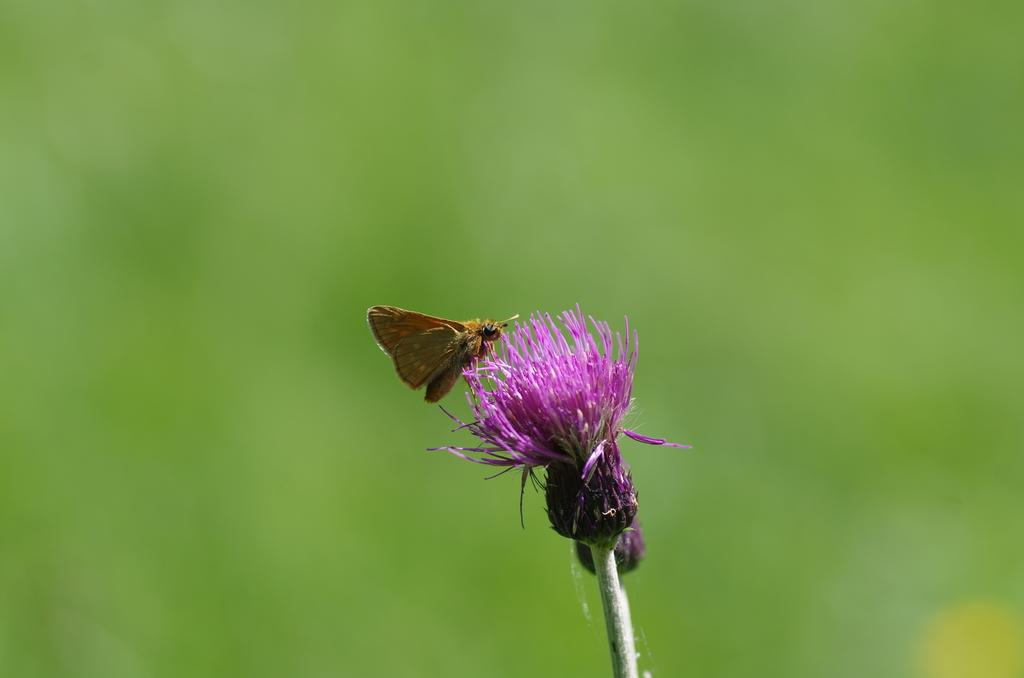What type of creature is in the image? There is an insect in the image. Where is the insect located? The insect is on a pink flower. Can you describe the background of the image? The background of the image is blurred, and the background color is green. What type of car is the judge driving in the image? There is no car or judge present in the image; it features an insect on a pink flower with a blurred green background. 